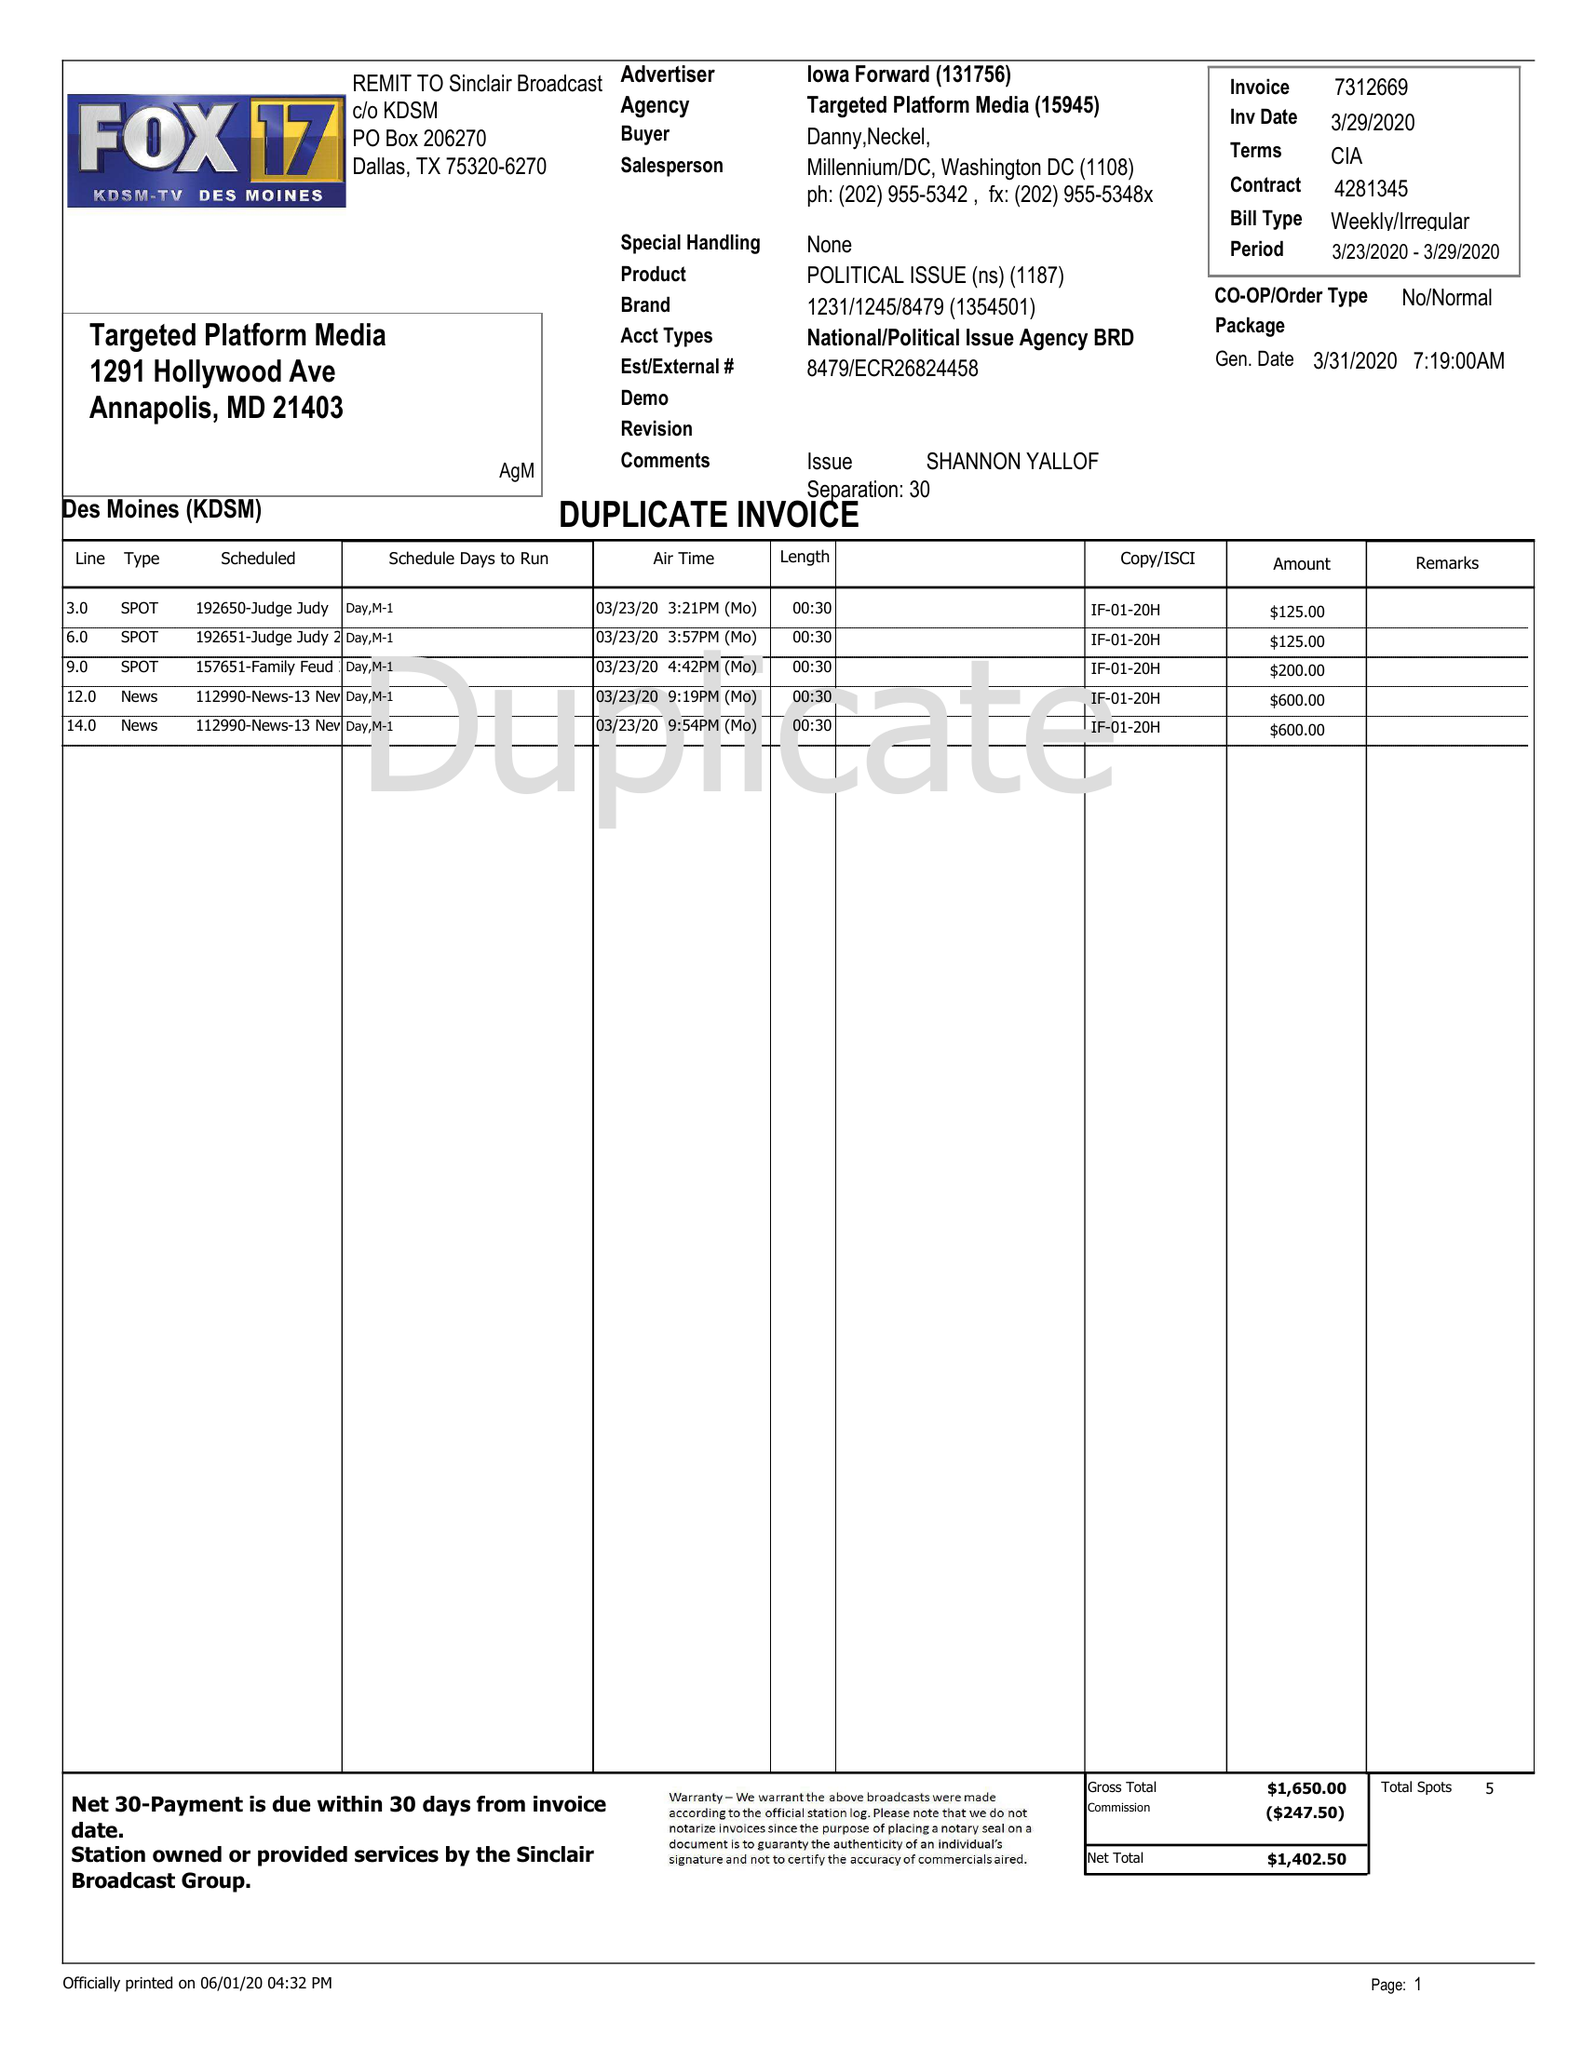What is the value for the contract_num?
Answer the question using a single word or phrase. 4281345 